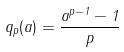Convert formula to latex. <formula><loc_0><loc_0><loc_500><loc_500>q _ { p } ( a ) = \frac { a ^ { p - 1 } - 1 } { p }</formula> 